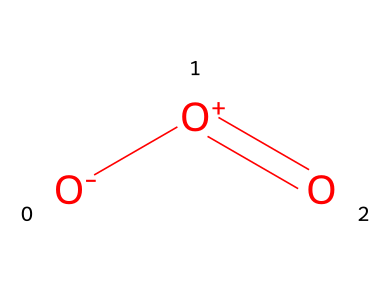What is the molecular formula of this chemical? The SMILES representation shows that there are three oxygen atoms, which can be noted from the presence of "O" in the structure. Therefore, the molecular formula is O3.
Answer: O3 How many bonds are present in this molecule? In the SMILES, you can see one double bond is indicated by "=O" between an oxygen atom and another oxygen, while the oxygen atoms also form bond types indicated by the brackets. Overall, there are 2 bonds (1 double and 1 single).
Answer: 2 Which element is the primary constituent of this chemical? The SMILES representation has only one type of atom, which is oxygen, denoted by "O" throughout. Therefore, the primary constituent is oxygen.
Answer: oxygen How does the charge affect the stability of this molecule? The molecule has a positive charge ([O+]) and a negative charge ([O-]), creating a resonance structure. The presence of these charges leads to instability but also contributes to its reactivity, specifically the formation of ozone in the atmosphere.
Answer: instability What type of gas is represented by this chemical structure? The structure indicates it is ozone, a type of gas found in the Earth's atmosphere, which plays a critical role in absorbing UV radiation.
Answer: ozone Is this molecule a pollutant in the atmosphere? Yes, due to its formation from reactions involving other pollutants and its ability to harm respiratory health at high concentrations, ozone is considered a pollutant.
Answer: yes 